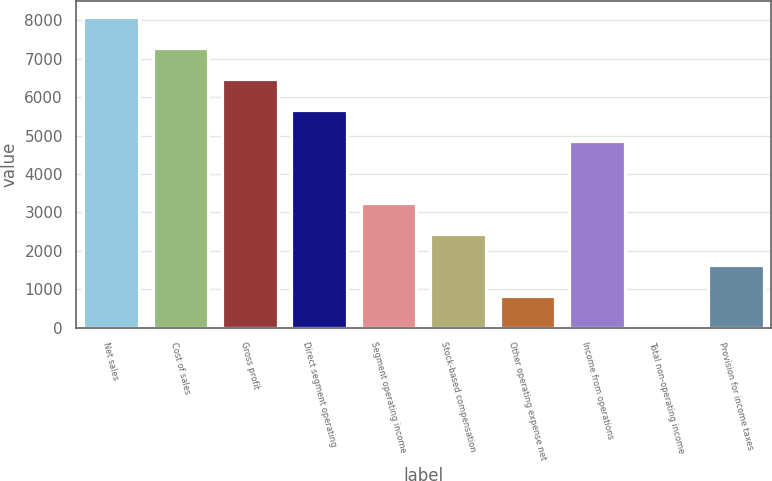Convert chart to OTSL. <chart><loc_0><loc_0><loc_500><loc_500><bar_chart><fcel>Net sales<fcel>Cost of sales<fcel>Gross profit<fcel>Direct segment operating<fcel>Segment operating income<fcel>Stock-based compensation<fcel>Other operating expense net<fcel>Income from operations<fcel>Total non-operating income<fcel>Provision for income taxes<nl><fcel>8095<fcel>7286<fcel>6477<fcel>5668<fcel>3241<fcel>2432<fcel>814<fcel>4859<fcel>5<fcel>1623<nl></chart> 